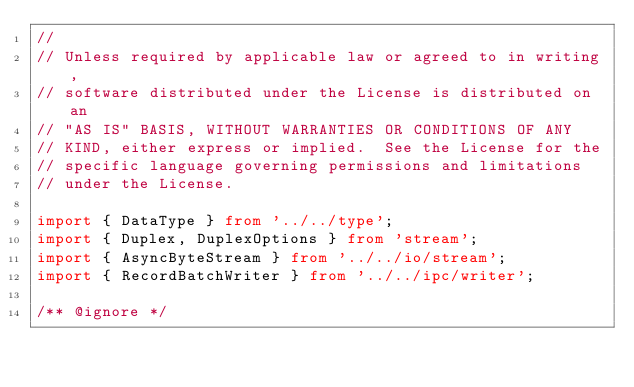<code> <loc_0><loc_0><loc_500><loc_500><_TypeScript_>//
// Unless required by applicable law or agreed to in writing,
// software distributed under the License is distributed on an
// "AS IS" BASIS, WITHOUT WARRANTIES OR CONDITIONS OF ANY
// KIND, either express or implied.  See the License for the
// specific language governing permissions and limitations
// under the License.

import { DataType } from '../../type';
import { Duplex, DuplexOptions } from 'stream';
import { AsyncByteStream } from '../../io/stream';
import { RecordBatchWriter } from '../../ipc/writer';

/** @ignore */</code> 